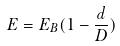<formula> <loc_0><loc_0><loc_500><loc_500>E = E _ { B } ( 1 - \frac { d } { D } )</formula> 